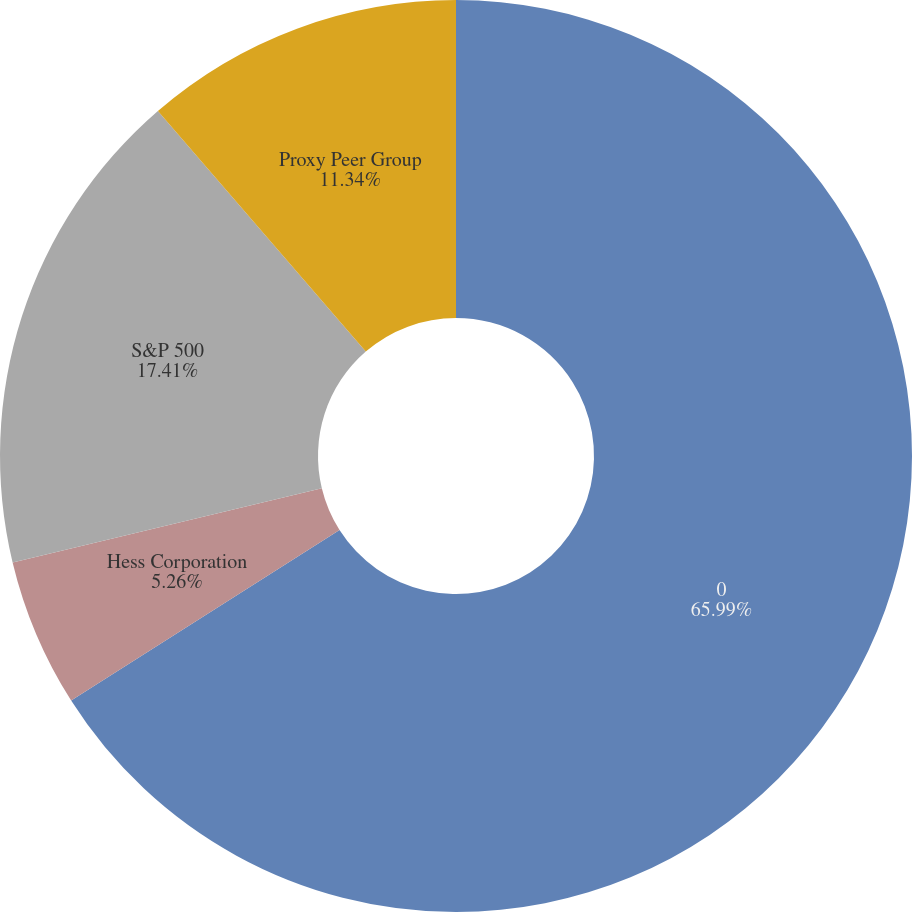Convert chart. <chart><loc_0><loc_0><loc_500><loc_500><pie_chart><fcel>0<fcel>Hess Corporation<fcel>S&P 500<fcel>Proxy Peer Group<nl><fcel>65.99%<fcel>5.26%<fcel>17.41%<fcel>11.34%<nl></chart> 